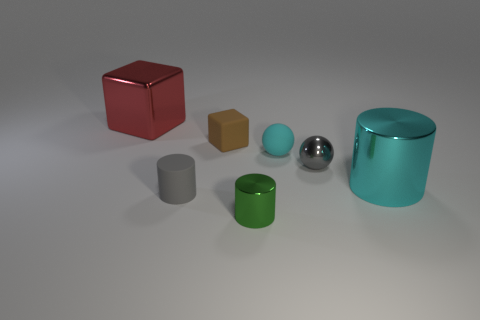Add 2 cyan balls. How many objects exist? 9 Subtract all blocks. How many objects are left? 5 Subtract all small brown rubber cubes. Subtract all tiny matte cubes. How many objects are left? 5 Add 6 tiny brown objects. How many tiny brown objects are left? 7 Add 5 metal blocks. How many metal blocks exist? 6 Subtract 0 green balls. How many objects are left? 7 